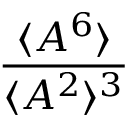<formula> <loc_0><loc_0><loc_500><loc_500>\frac { \langle A ^ { 6 } \rangle } { \langle A ^ { 2 } \rangle ^ { 3 } }</formula> 